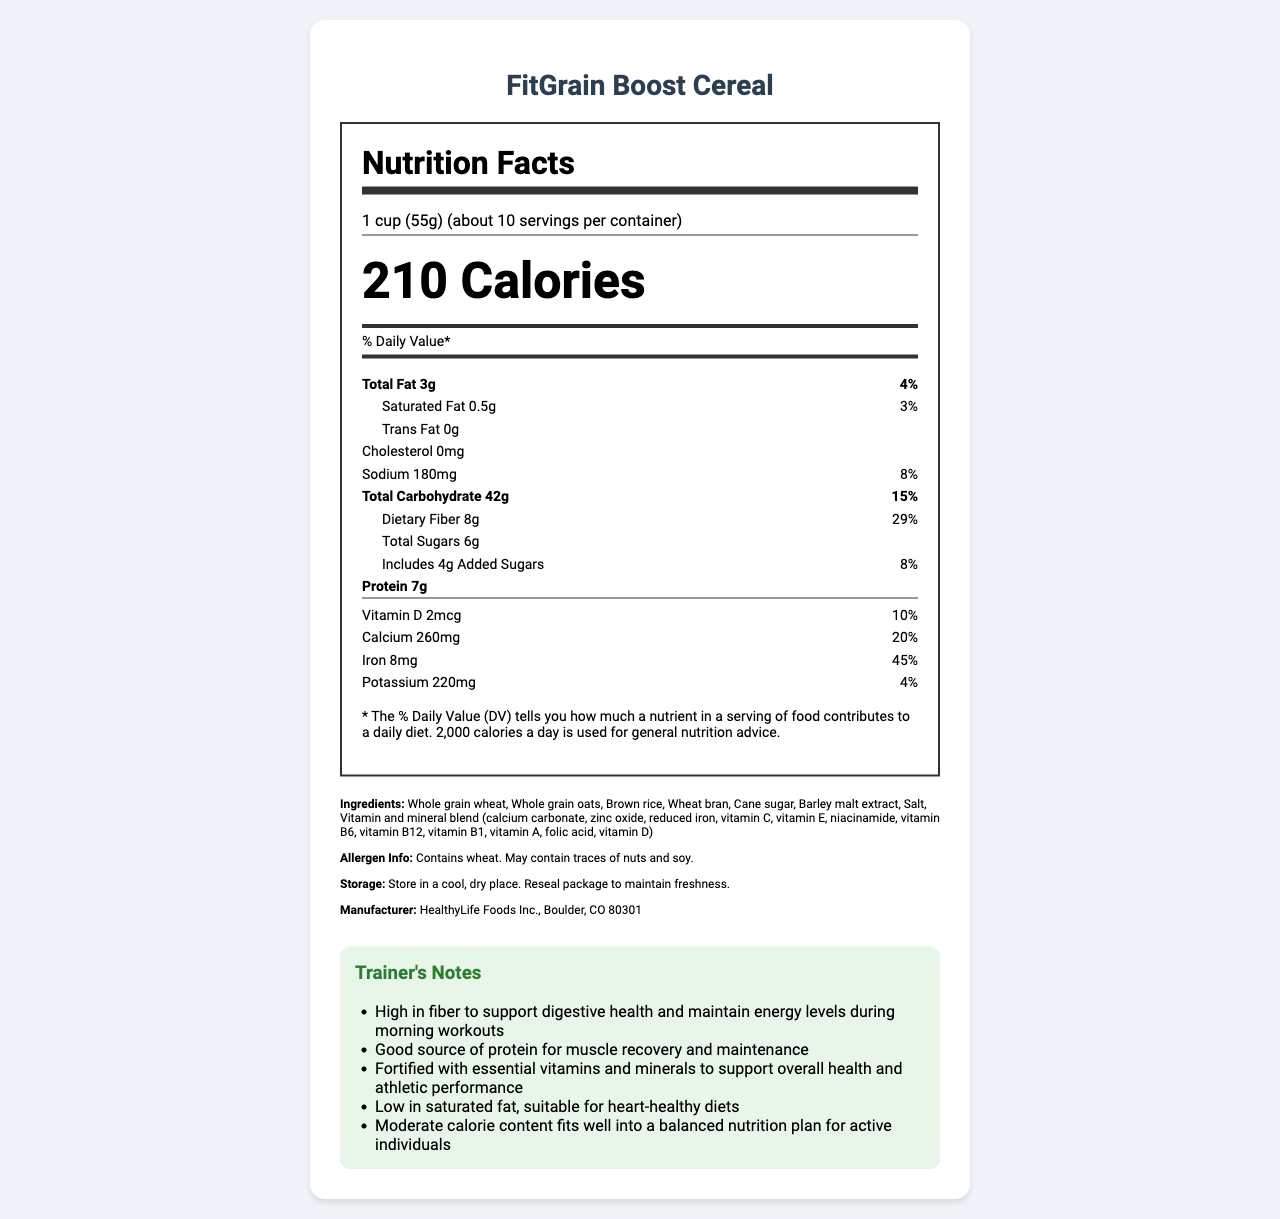how many calories are in a serving of FitGrain Boost Cereal? The calories per serving are there as 210, located in the middle of the nutrition label.
Answer: 210 what is the daily value percentage for dietary fiber? This is listed under the "Total Carbohydrate" section.
Answer: 29% what is the serving size for this cereal? The serving size is shown at the top of the nutrition label.
Answer: 1 cup (55g) how much protein does one serving have? Protein content is prominently displayed in bold text in the nutrient section.
Answer: 7g how many servings are in the container? Serving info shows "about 10" servings per container.
Answer: about 10 which vitamin has the highest daily value percentage? A. Vitamin D B. Calcium C. Iron D. Vitamin B12 Vitamin B12 has the highest daily value percentage at 50%.
Answer: D how much sodium is in a serving? A. 150mg B. 180mg C. 220mg D. 260mg Sodium content is given as 180mg.
Answer: B does the cereal contain any trans fat? The amount of trans fat per serving is listed as 0g.
Answer: No is the cereal suitable for individuals looking to maintain a heart-healthy diet? The trainer's notes state that the cereal is low in saturated fat, suitable for heart-healthy diets.
Answer: Yes which vitamins are included in the cereal? These vitamins are listed in the detailed breakdown in the vitamins section.
Answer: A, C, D, E, B1, B6, B12, Niacin, Folate what allergens are contained in this cereal? Allergen info states this information clearly.
Answer: Wheat, may contain traces of nuts and soy describe the nutrition facts and additional info for FitGrain Boost Cereal. The document provides comprehensive nutrition information, ingredient details, allergen info, storage instructions, and trainer notes that highlight the health benefits of the cereal.
Answer: The nutrition facts label for FitGrain Boost Cereal details the serving size, calorie count, and nutritional content, including significant amounts of vitamins, minerals, and dietary fiber. It also includes allergen information, storage instructions, the manufacturer, and trainer's notes on the cereal's benefits for digestive health, protein content, vitamin fortification, low saturated fat, and suitability for active individuals. is this cereal gluten-free? The document does not provide info on whether the cereal is gluten-free.
Answer: Cannot be determined what are the main ingredients in FitGrain Boost Cereal? These ingredients are listed under the ingredients section.
Answer: Whole grain wheat, whole grain oats, brown rice, wheat bran, cane sugar, barley malt extract, salt, vitamin and mineral blend 